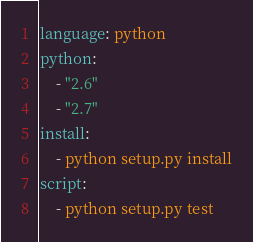<code> <loc_0><loc_0><loc_500><loc_500><_YAML_>language: python
python: 
    - "2.6"
    - "2.7"
install:
    - python setup.py install
script: 
    - python setup.py test
</code> 